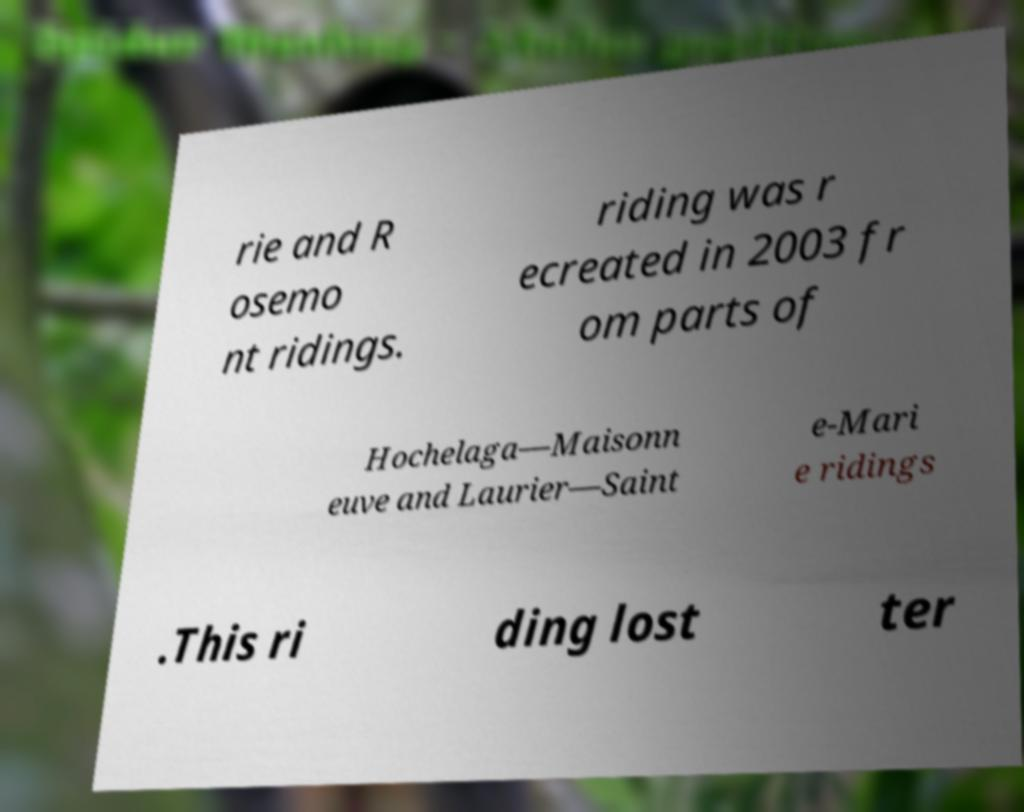Could you assist in decoding the text presented in this image and type it out clearly? rie and R osemo nt ridings. riding was r ecreated in 2003 fr om parts of Hochelaga—Maisonn euve and Laurier—Saint e-Mari e ridings .This ri ding lost ter 